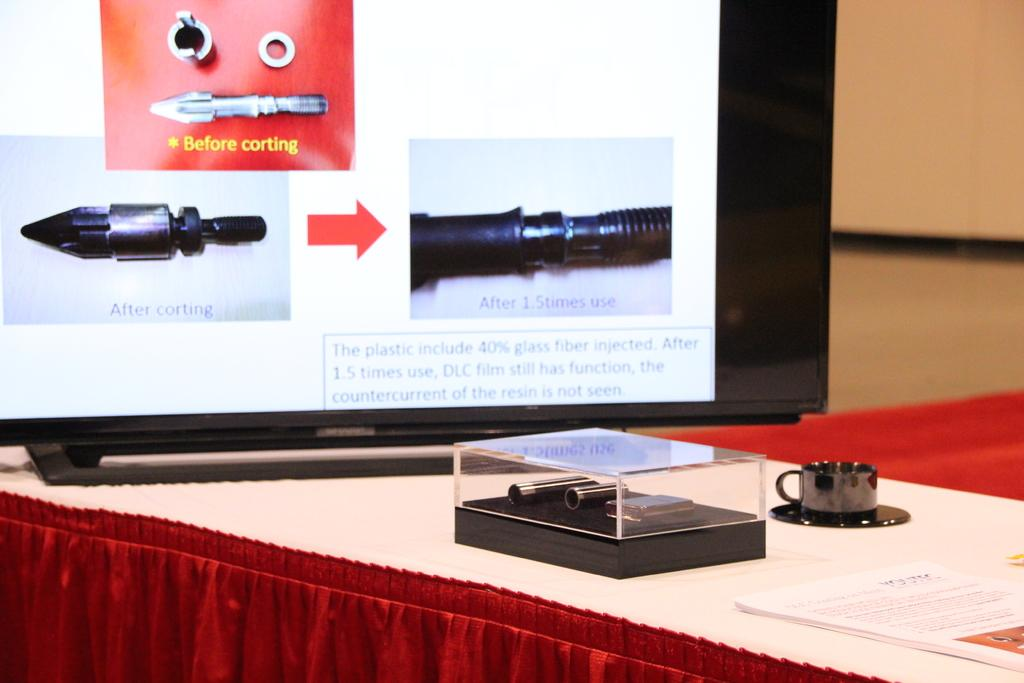What type of objects can be seen on the table in the image? There are papers, a cup with a saucer, a glass box with bullets, and a television with bullets photos on the screen on the table in the image. What is the purpose of the glass box in the image? The glass box is used to store the bullets in the image. What is being displayed on the television in the image? The television in the image is showing photos of bullets. How are the papers arranged on the table in the image? The provided facts do not specify the arrangement of the papers on the table. Can you see a statement written on the papers in the image? There is no mention of a statement written on the papers in the image. 